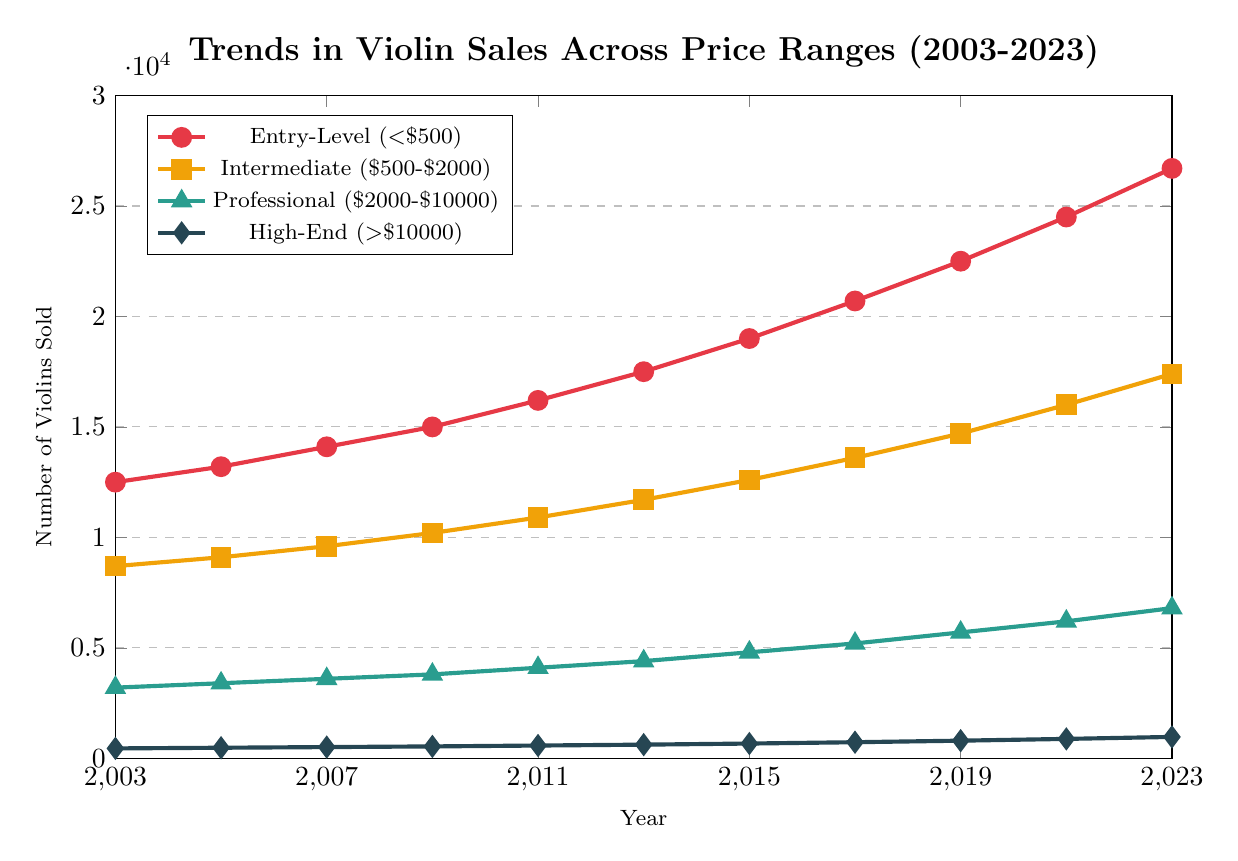What was the trend in sales for Entry-Level violins between 2003 and 2023? To determine the trend, we review the sales data for Entry-Level violins from 2003 to 2023. Sales increased steadily from 12,500 in 2003 to 26,700 in 2023, indicating a rising trend.
Answer: Increasing Which year did Entry-Level violins surpass 20,000 units sold? Review the data points for Entry-Level violins. The sales surpassed 20,000 units in 2017 with 20,700 sold.
Answer: 2017 What is the difference in the number of Intermediate violins sold between 2005 and 2015? Find the sales figures for Intermediate violins: 9,100 in 2005 and 12,600 in 2015. The difference is calculated as 12,600 - 9,100 = 3,500.
Answer: 3,500 In which year did Professional violins first exceed 5,000 units sold? Check the data for Professional violins. They exceeded 5,000 units in 2017, with 5,200 sold.
Answer: 2017 How many more Entry-Level violins were sold compared to High-End violins in 2023? To find the difference, look at the 2023 sales: 26,700 for Entry-Level and 970 for High-End. The difference is 26,700 - 970 = 25,730.
Answer: 25,730 What is the average increase per year in sales for Intermediate violins from 2003 to 2023? Calculate the total increase from 2003 to 2023 (17,400 - 8,700 = 8,700) and the number of years (2023-2003 = 20). The average increase per year is 8,700 / 20 = 435.
Answer: 435 Which price range had the highest sales growth rate from 2003 to 2023? Calculate the sales growth for each range. Entry-Level increased by 26,700 - 12,500 = 14,200, Intermediate by 17,400 - 8,700 = 8,700, Professional by 6,800 - 3,200 = 3,600, and High-End by 970 - 450 = 520. Entry-Level has the highest absolute growth.
Answer: Entry-Level What was the percentage increase in sales for High-End violins from 2003 to 2023? Calculate the percentage increase using (New Value - Old Value) / Old Value * 100. For High-End, (970 - 450) / 450 * 100 = 115.6%.
Answer: 115.6% In which year did Intermediate violins' sales first exceed those of Professional violins by more than double? Check the data year by year. In 2003, Intermediate sales (8,700) were already more than double Professional sales (3,200). Validate higher ratios in subsequent years to confirm earliest occurrence.
Answer: 2003 How does the sales trend for Professional violins compare to that of High-End violins over the years? Analyze the data for trends: Professional violins saw a steady increase from 3,200 in 2003 to 6,800 in 2023, while High-End violins increased from 450 in 2003 to 970 in 2023. Both show growth, but Professional violins had a larger absolute increase.
Answer: Both increased, larger increase for Professional violins 